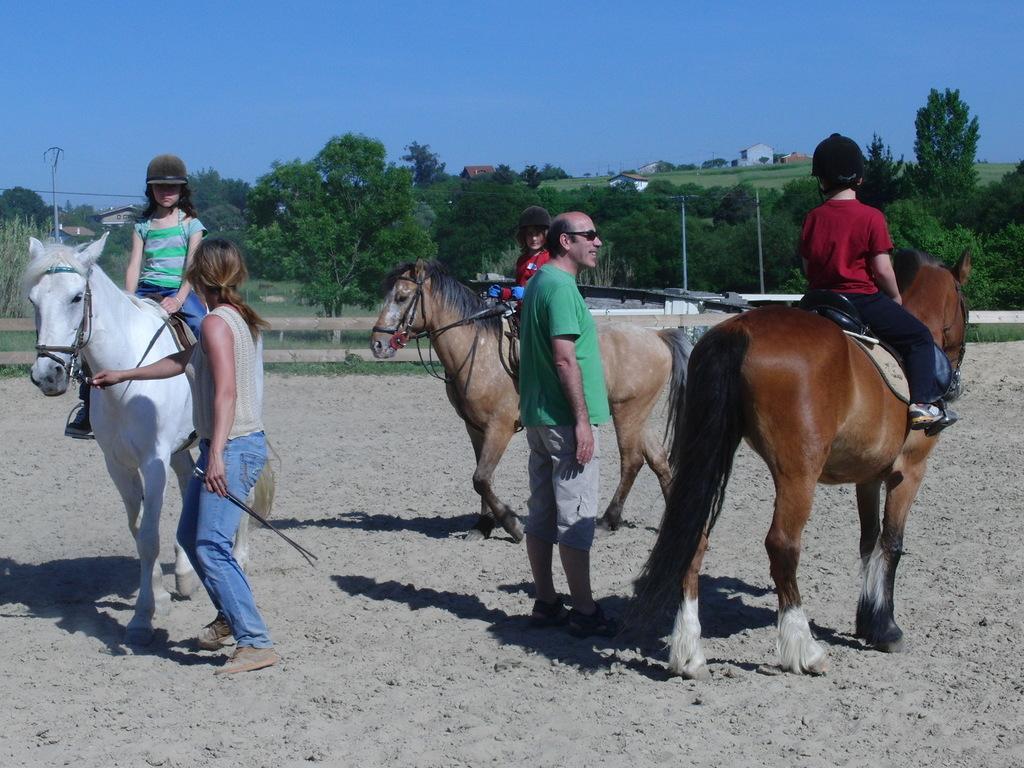In one or two sentences, can you explain what this image depicts? This picture describes about group of people and few kids sitting on the horses, in the background we can see few trees, poles and houses. 